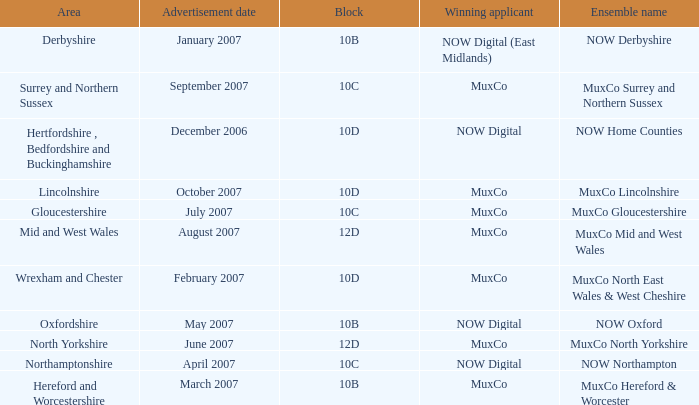What is Ensemble Name Muxco Gloucestershire's Advertisement Date in Block 10C? July 2007. 